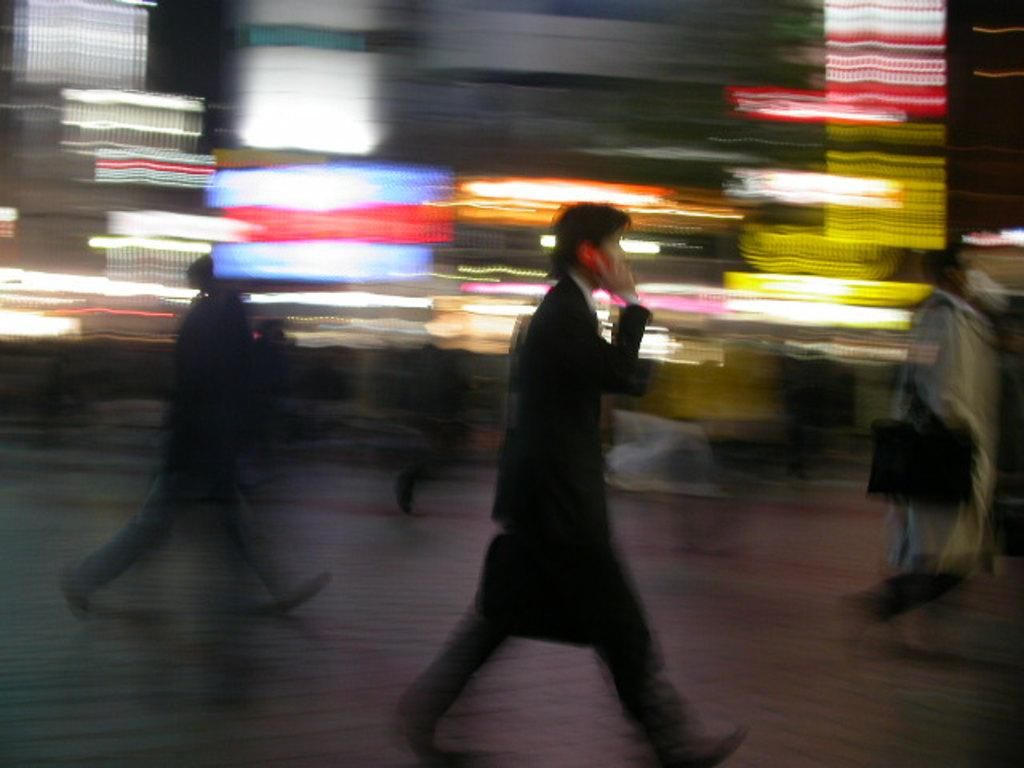What are the people in the image doing? The people in the image are walking on the road. What object can be seen with the people in the image? There is a bag visible in the image. What electronic device is present in the image? There is a mobile in the image. What can be seen in the background of the image? There are lights in the background of the image. What title does the river in the image have? There is no river present in the image, so it does not have a title. 